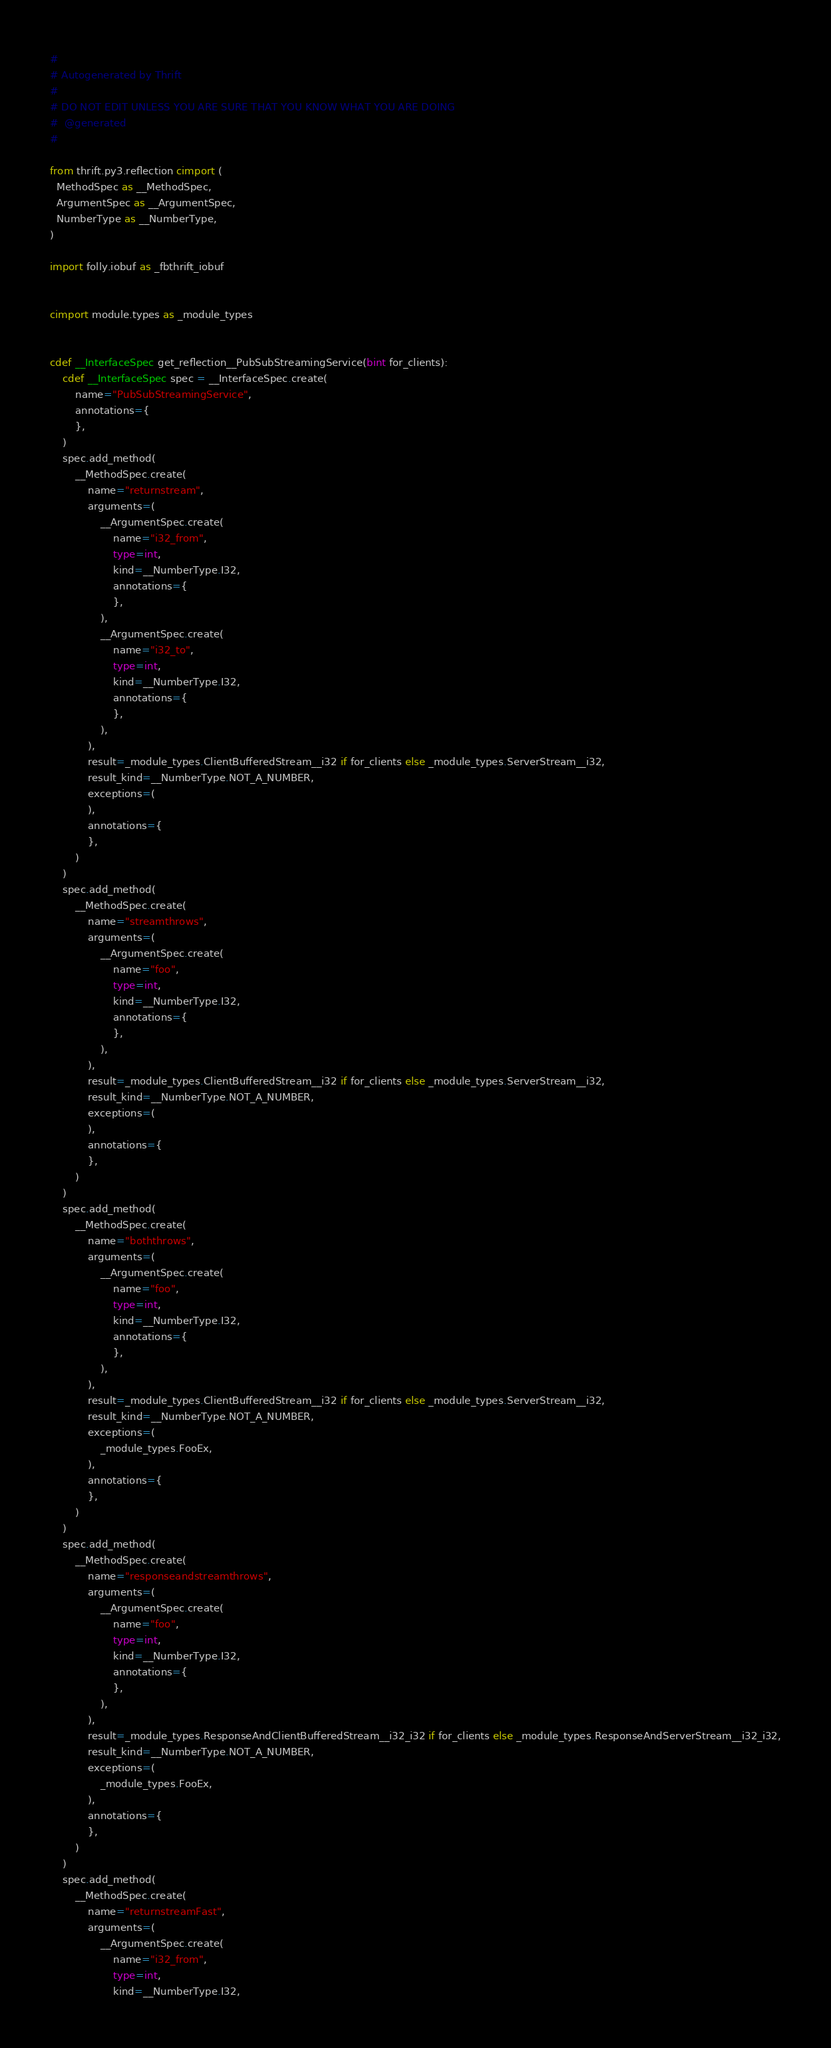Convert code to text. <code><loc_0><loc_0><loc_500><loc_500><_Cython_>#
# Autogenerated by Thrift
#
# DO NOT EDIT UNLESS YOU ARE SURE THAT YOU KNOW WHAT YOU ARE DOING
#  @generated
#

from thrift.py3.reflection cimport (
  MethodSpec as __MethodSpec,
  ArgumentSpec as __ArgumentSpec,
  NumberType as __NumberType,
)

import folly.iobuf as _fbthrift_iobuf


cimport module.types as _module_types


cdef __InterfaceSpec get_reflection__PubSubStreamingService(bint for_clients):
    cdef __InterfaceSpec spec = __InterfaceSpec.create(
        name="PubSubStreamingService",
        annotations={
        },
    )
    spec.add_method(
        __MethodSpec.create(
            name="returnstream",
            arguments=(
                __ArgumentSpec.create(
                    name="i32_from",
                    type=int,
                    kind=__NumberType.I32,
                    annotations={
                    },
                ),
                __ArgumentSpec.create(
                    name="i32_to",
                    type=int,
                    kind=__NumberType.I32,
                    annotations={
                    },
                ),
            ),
            result=_module_types.ClientBufferedStream__i32 if for_clients else _module_types.ServerStream__i32,
            result_kind=__NumberType.NOT_A_NUMBER,
            exceptions=(
            ),
            annotations={
            },
        )
    )
    spec.add_method(
        __MethodSpec.create(
            name="streamthrows",
            arguments=(
                __ArgumentSpec.create(
                    name="foo",
                    type=int,
                    kind=__NumberType.I32,
                    annotations={
                    },
                ),
            ),
            result=_module_types.ClientBufferedStream__i32 if for_clients else _module_types.ServerStream__i32,
            result_kind=__NumberType.NOT_A_NUMBER,
            exceptions=(
            ),
            annotations={
            },
        )
    )
    spec.add_method(
        __MethodSpec.create(
            name="boththrows",
            arguments=(
                __ArgumentSpec.create(
                    name="foo",
                    type=int,
                    kind=__NumberType.I32,
                    annotations={
                    },
                ),
            ),
            result=_module_types.ClientBufferedStream__i32 if for_clients else _module_types.ServerStream__i32,
            result_kind=__NumberType.NOT_A_NUMBER,
            exceptions=(
                _module_types.FooEx,
            ),
            annotations={
            },
        )
    )
    spec.add_method(
        __MethodSpec.create(
            name="responseandstreamthrows",
            arguments=(
                __ArgumentSpec.create(
                    name="foo",
                    type=int,
                    kind=__NumberType.I32,
                    annotations={
                    },
                ),
            ),
            result=_module_types.ResponseAndClientBufferedStream__i32_i32 if for_clients else _module_types.ResponseAndServerStream__i32_i32,
            result_kind=__NumberType.NOT_A_NUMBER,
            exceptions=(
                _module_types.FooEx,
            ),
            annotations={
            },
        )
    )
    spec.add_method(
        __MethodSpec.create(
            name="returnstreamFast",
            arguments=(
                __ArgumentSpec.create(
                    name="i32_from",
                    type=int,
                    kind=__NumberType.I32,</code> 